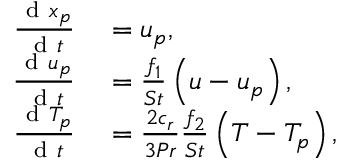Convert formula to latex. <formula><loc_0><loc_0><loc_500><loc_500>\begin{array} { r l } { \frac { d x _ { p } } { d t } } & = u _ { p } , } \\ { \frac { d u _ { p } } { d t } } & = \frac { f _ { 1 } } { S t } \left ( u - u _ { p } \right ) , } \\ { \frac { d T _ { p } } { d t } } & = \frac { 2 c _ { r } } { 3 P r } \frac { f _ { 2 } } { S t } \left ( T - T _ { p } \right ) , } \end{array}</formula> 